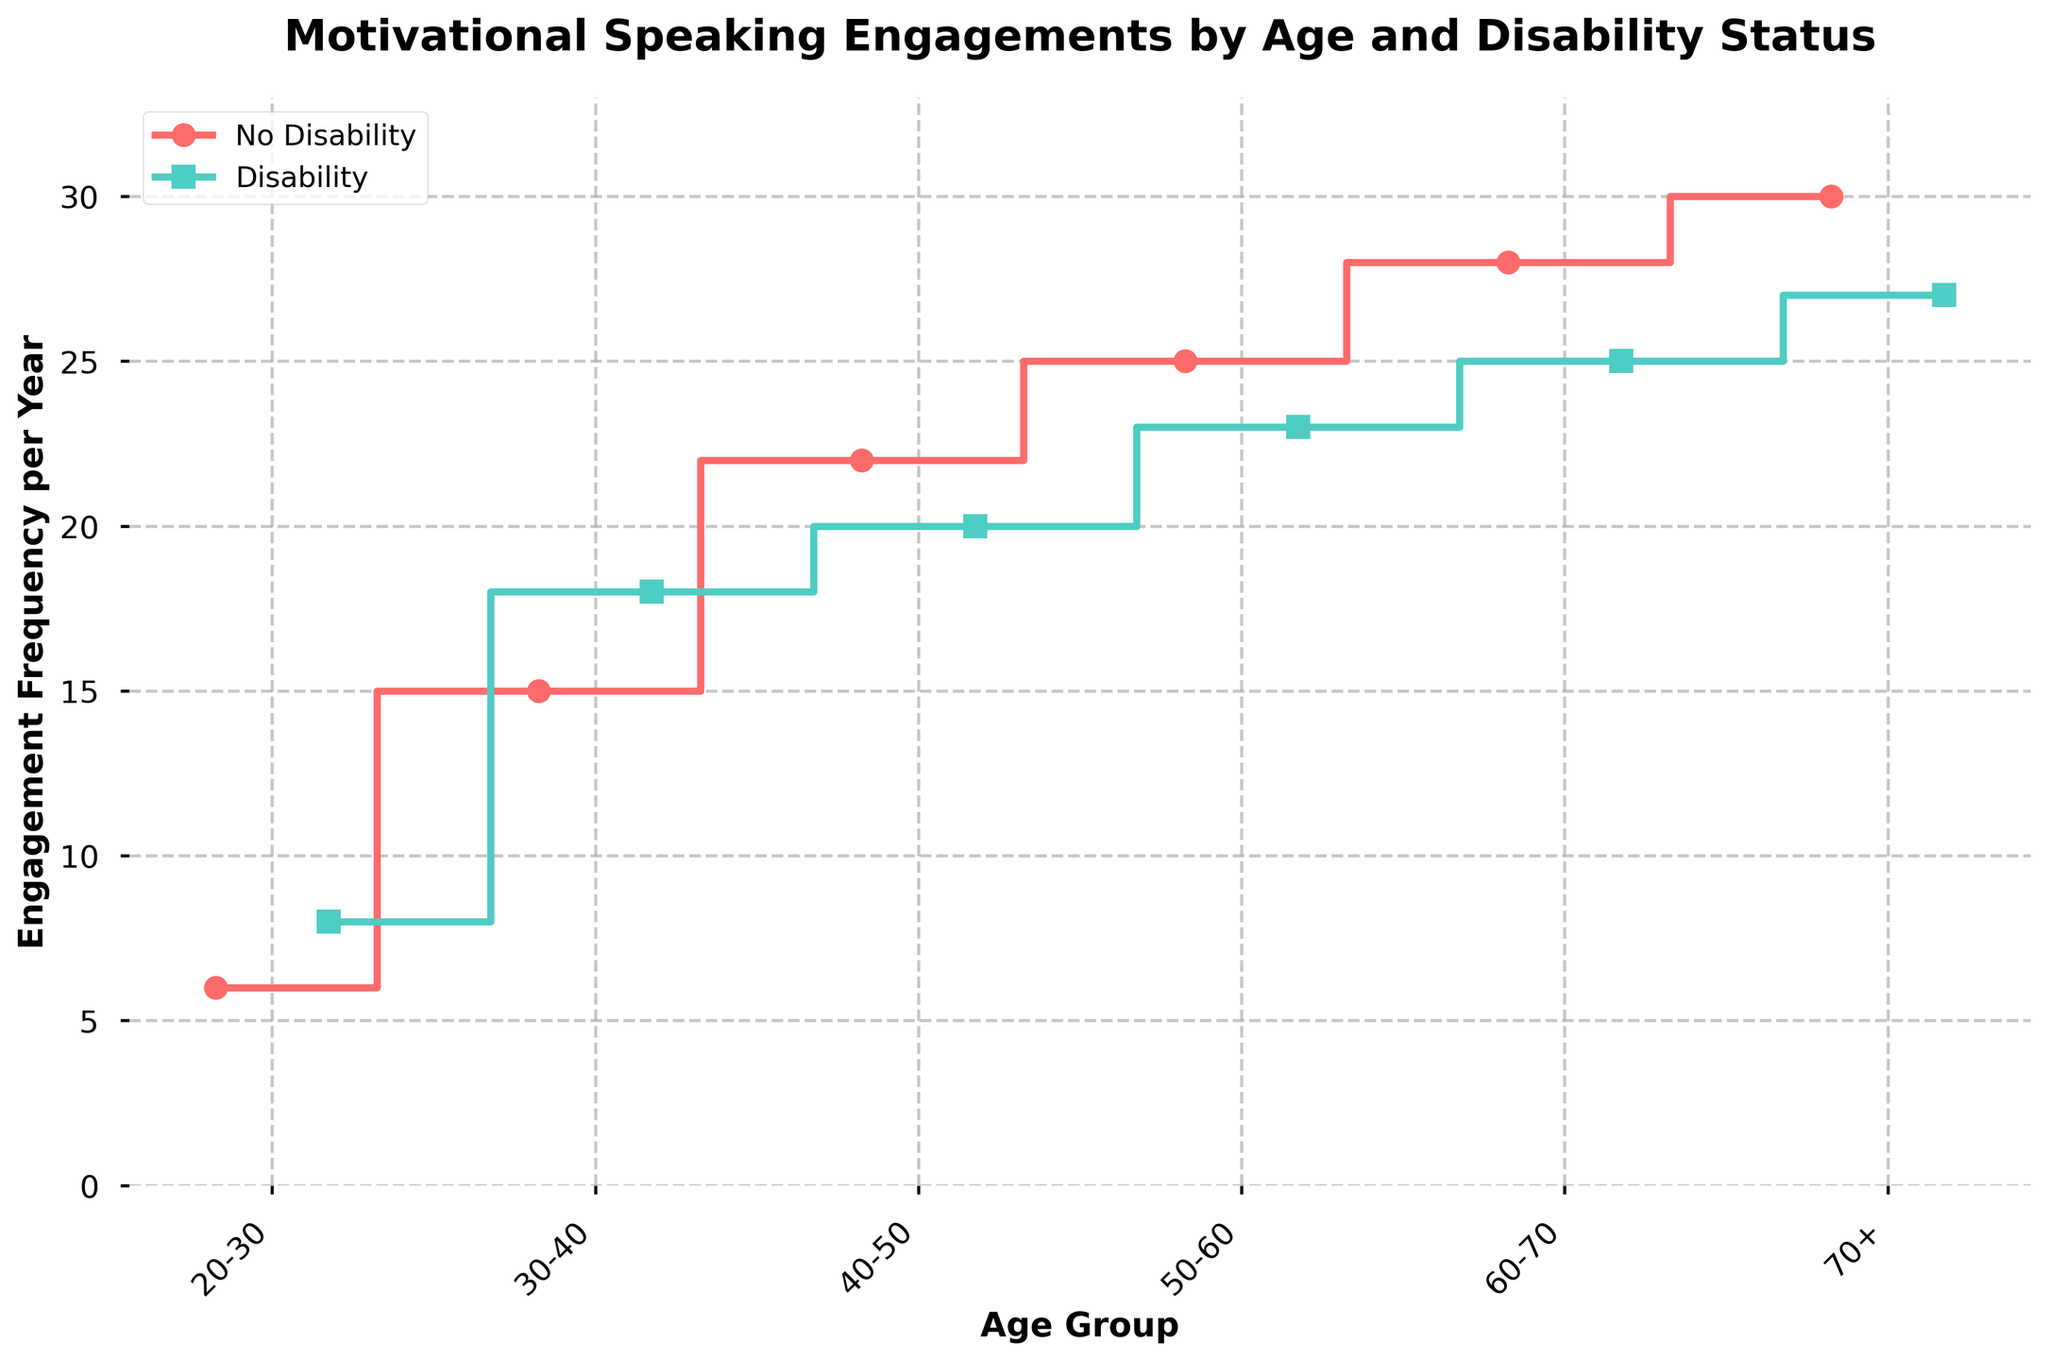What's the title of the figure? Look at the text at the top center of the figure. It indicates the main topic of the plot.
Answer: Motivational Speaking Engagements by Age and Disability Status What's the color used to represent "No Disability"? Look at the legend near the top left of the figure. The color associated with "No Disability" is indicated.
Answer: Red In the age group 60-70, which Disability Status has a higher engagement frequency? Locate the data points for the 60-70 age group on the x-axis and compare the heights of the steps. The taller step represents higher frequency.
Answer: No Disability How does the engagement frequency change from age group 40-50 to 50-60 for those with a Disability? Identify the points for ages 40-50 and 50-60 for the Disability line and calculate the difference between these points.
Answer: The frequency decreases from 20 to 23, a change of +3 What's the maximum engagement frequency for those with a Disability? Compare the highest values of the steps for "Disability" across all age groups.
Answer: 27 Is there any age group where persons with a Disability have a higher engagement frequency than those with No Disability? Compare each corresponding pair of steps for all age groups to check if the "Disability" step is higher than the "No Disability" step.
Answer: Yes, in the age group 20-30 What's the average engagement frequency for persons with No Disability across all age groups? Sum the engagement frequencies of all age groups for "No Disability" and divide by the number of age groups (6). (6 + 15 + 22 + 25 + 28 + 30) / 6 = 21
Answer: 21 What is the trend shown by persons with No Disability as they age from 20-30 to 70+? Observe the steps representing "No Disability" and whether they increase, decrease, or remain constant as the age groups progress.
Answer: The engagement frequency generally increases with age 